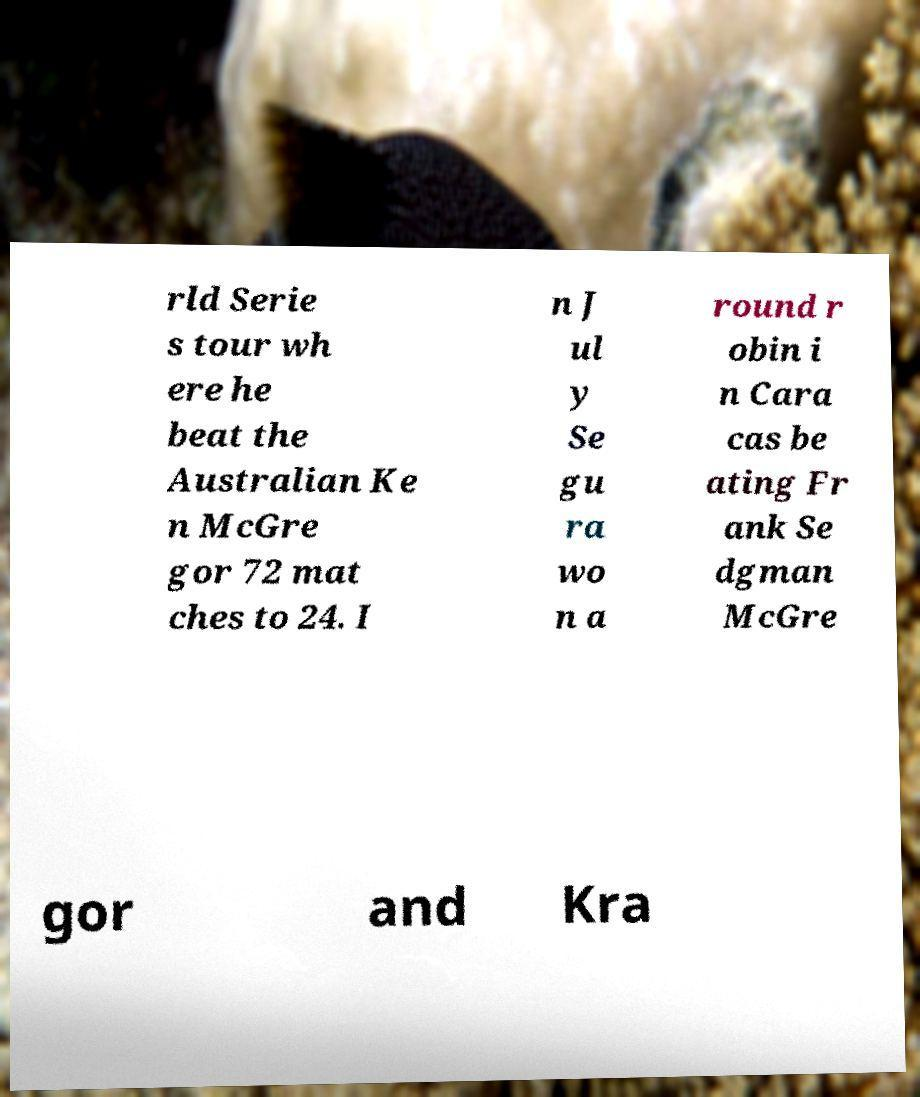What messages or text are displayed in this image? I need them in a readable, typed format. rld Serie s tour wh ere he beat the Australian Ke n McGre gor 72 mat ches to 24. I n J ul y Se gu ra wo n a round r obin i n Cara cas be ating Fr ank Se dgman McGre gor and Kra 